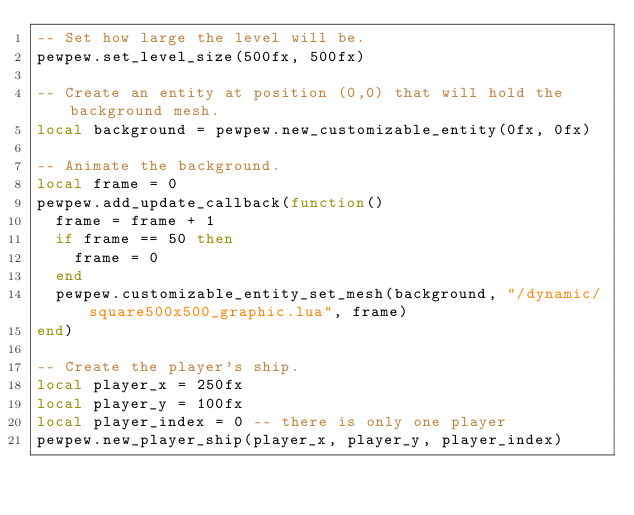Convert code to text. <code><loc_0><loc_0><loc_500><loc_500><_Lua_>-- Set how large the level will be.
pewpew.set_level_size(500fx, 500fx)

-- Create an entity at position (0,0) that will hold the background mesh.
local background = pewpew.new_customizable_entity(0fx, 0fx)

-- Animate the background.
local frame = 0
pewpew.add_update_callback(function()
  frame = frame + 1
  if frame == 50 then
    frame = 0
  end
  pewpew.customizable_entity_set_mesh(background, "/dynamic/square500x500_graphic.lua", frame)
end)

-- Create the player's ship.
local player_x = 250fx
local player_y = 100fx
local player_index = 0 -- there is only one player
pewpew.new_player_ship(player_x, player_y, player_index)
</code> 